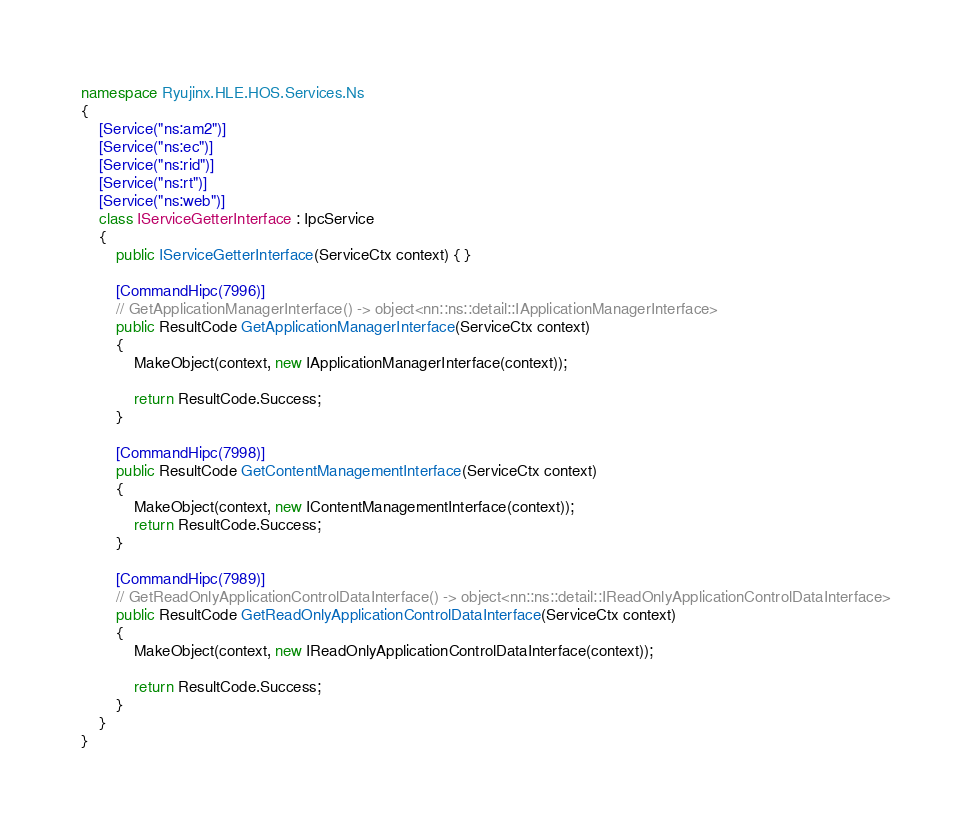<code> <loc_0><loc_0><loc_500><loc_500><_C#_>namespace Ryujinx.HLE.HOS.Services.Ns
{
    [Service("ns:am2")]
    [Service("ns:ec")]
    [Service("ns:rid")]
    [Service("ns:rt")]
    [Service("ns:web")]
    class IServiceGetterInterface : IpcService
    {
        public IServiceGetterInterface(ServiceCtx context) { }

        [CommandHipc(7996)]
        // GetApplicationManagerInterface() -> object<nn::ns::detail::IApplicationManagerInterface>
        public ResultCode GetApplicationManagerInterface(ServiceCtx context)
        {
            MakeObject(context, new IApplicationManagerInterface(context));

            return ResultCode.Success;
        }

        [CommandHipc(7998)]
        public ResultCode GetContentManagementInterface(ServiceCtx context)
        {
            MakeObject(context, new IContentManagementInterface(context));
            return ResultCode.Success;
        }

        [CommandHipc(7989)]
        // GetReadOnlyApplicationControlDataInterface() -> object<nn::ns::detail::IReadOnlyApplicationControlDataInterface>
        public ResultCode GetReadOnlyApplicationControlDataInterface(ServiceCtx context)
        {
            MakeObject(context, new IReadOnlyApplicationControlDataInterface(context));

            return ResultCode.Success;
        }
    }
}</code> 